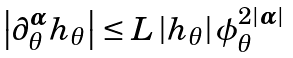<formula> <loc_0><loc_0><loc_500><loc_500>\left | \partial _ { \theta } ^ { \boldsymbol \alpha } h _ { \theta } \right | \leq L \left | h _ { \theta } \right | \phi _ { \theta } ^ { 2 | \boldsymbol \alpha | }</formula> 